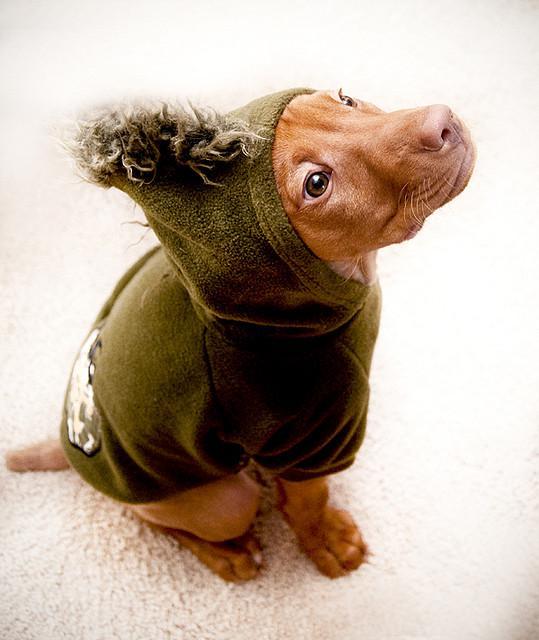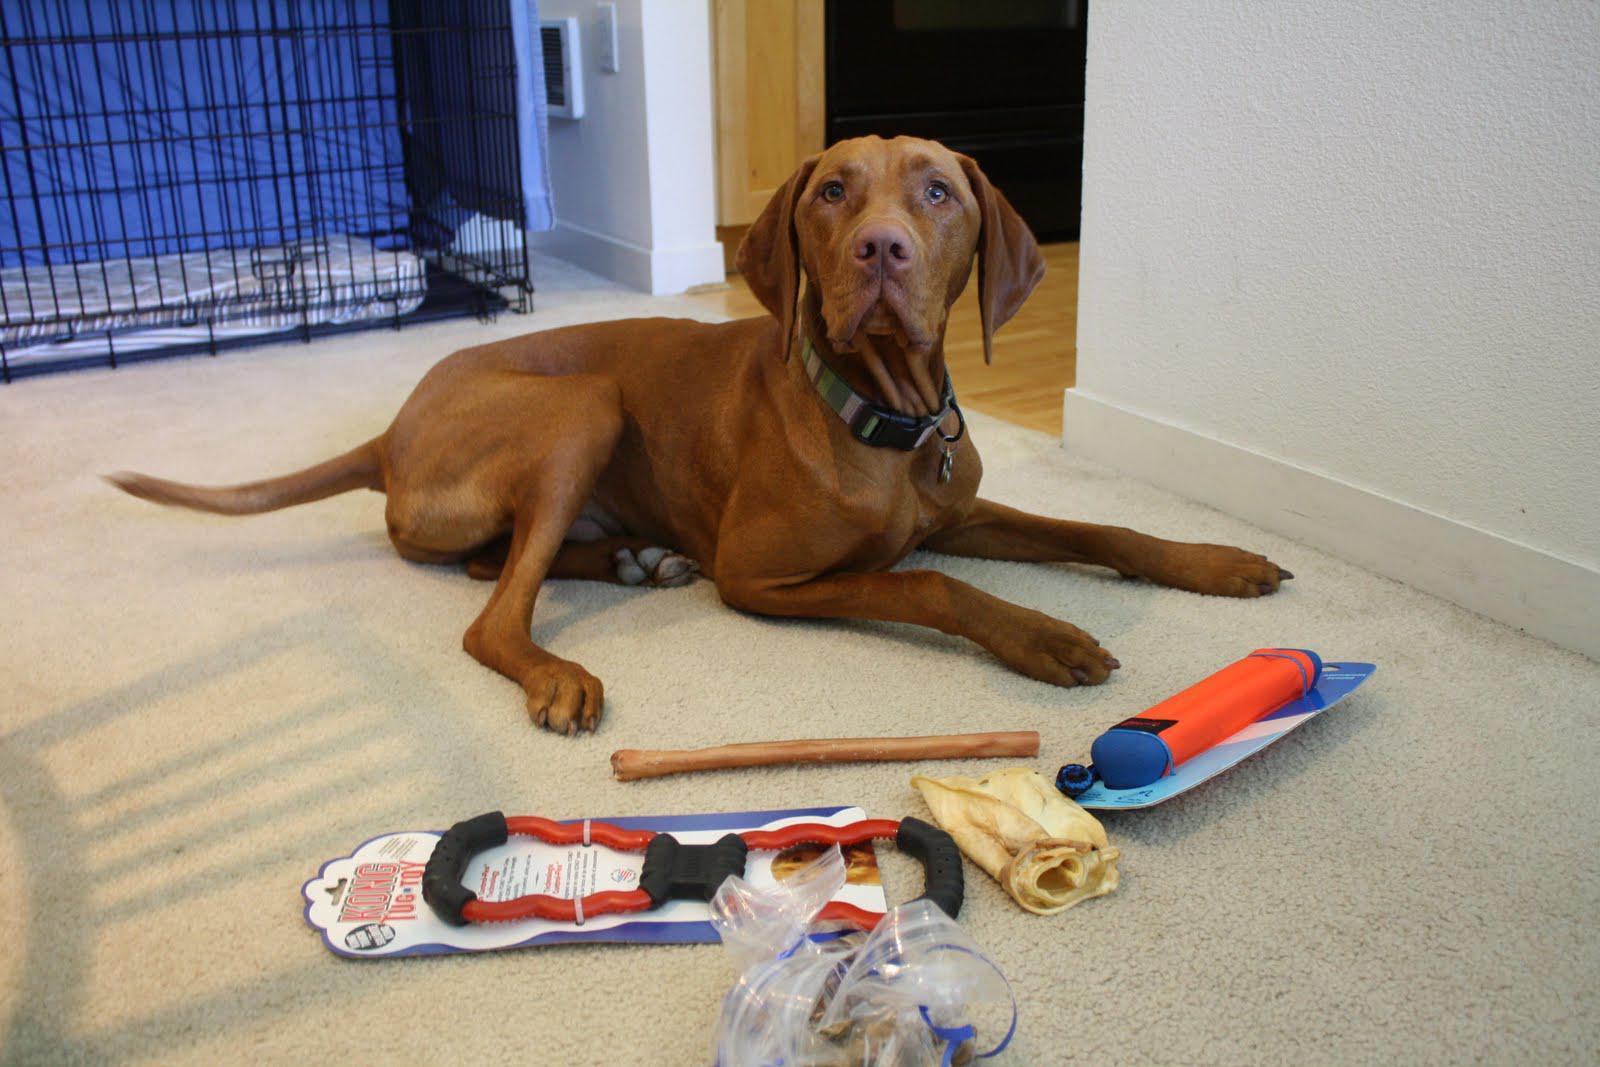The first image is the image on the left, the second image is the image on the right. Examine the images to the left and right. Is the description "The dog on the right is reclining with front paws stretched in front of him and head raised, and the dog on the left is sitting uprgiht and wearing a pullover top." accurate? Answer yes or no. Yes. 